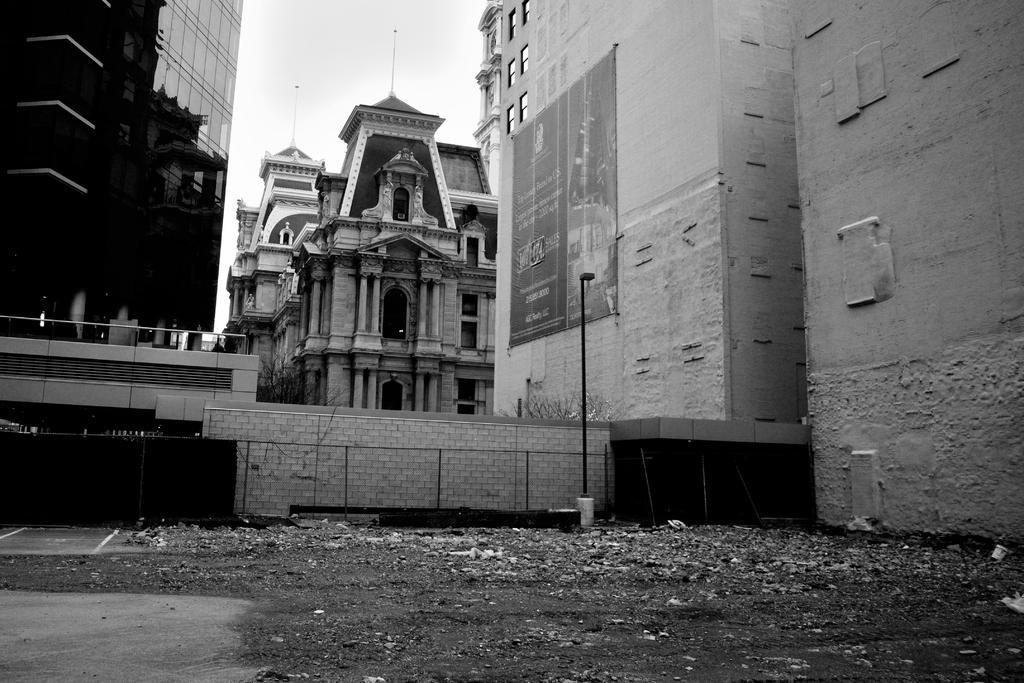How would you summarize this image in a sentence or two? In this picture there are buildings and trees and there is a board on the building and there is text on the board. At the top there is sky. At the bottom there is garbage. In the foreground there is a railing. On the left side of the image there is a reflection of a building on the glass. 